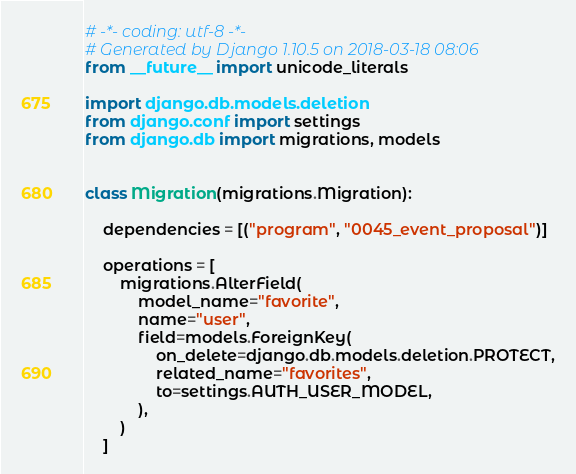Convert code to text. <code><loc_0><loc_0><loc_500><loc_500><_Python_># -*- coding: utf-8 -*-
# Generated by Django 1.10.5 on 2018-03-18 08:06
from __future__ import unicode_literals

import django.db.models.deletion
from django.conf import settings
from django.db import migrations, models


class Migration(migrations.Migration):

    dependencies = [("program", "0045_event_proposal")]

    operations = [
        migrations.AlterField(
            model_name="favorite",
            name="user",
            field=models.ForeignKey(
                on_delete=django.db.models.deletion.PROTECT,
                related_name="favorites",
                to=settings.AUTH_USER_MODEL,
            ),
        )
    ]
</code> 